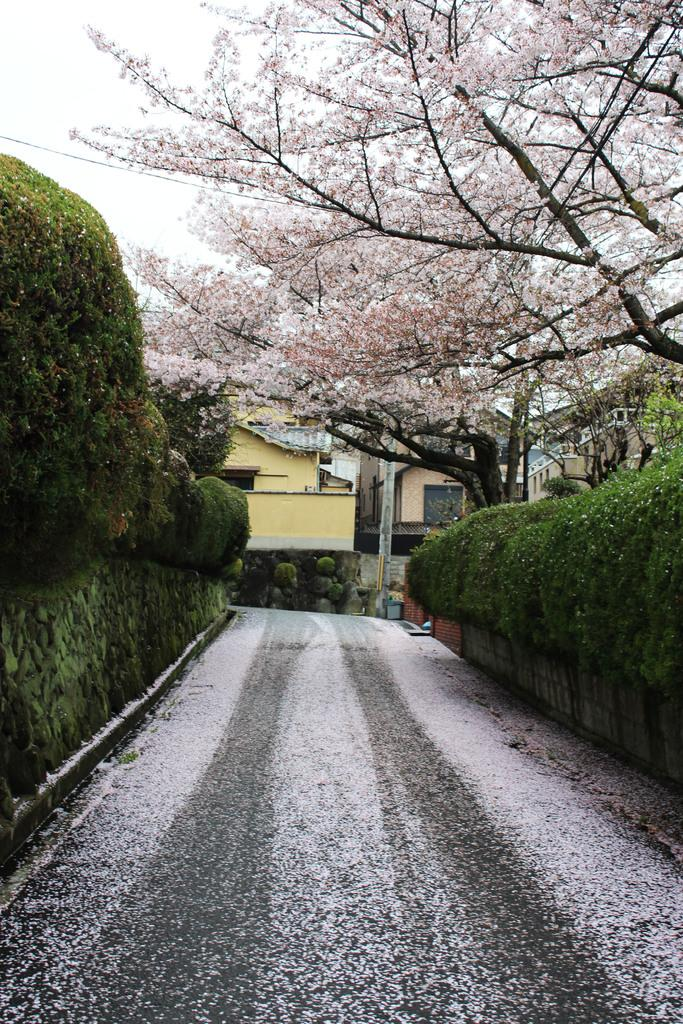What type of vegetation can be seen in the image? There are plants, trees, and flowers in the image. What is the primary structure visible in the image? There is a wall in the image. What can be seen in the background of the image? There are houses and the sky visible in the background of the image. What type of rock is being used to drive the oven in the image? There is no rock or oven present in the image. 